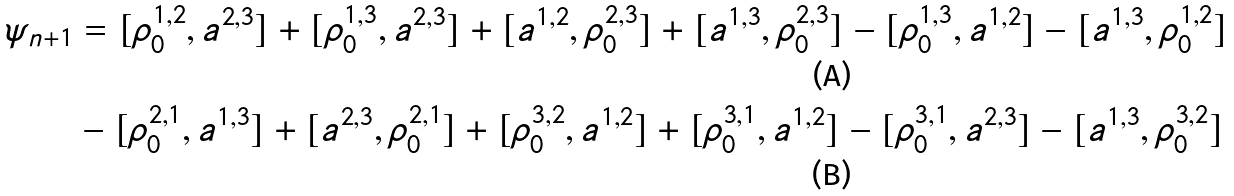<formula> <loc_0><loc_0><loc_500><loc_500>\psi _ { n + 1 } & = [ \rho _ { 0 } ^ { 1 , 2 } , a ^ { 2 , 3 } ] + [ \rho _ { 0 } ^ { 1 , 3 } , a ^ { 2 , 3 } ] + [ a ^ { 1 , 2 } , \rho _ { 0 } ^ { 2 , 3 } ] + [ a ^ { 1 , 3 } , \rho _ { 0 } ^ { 2 , 3 } ] - [ \rho _ { 0 } ^ { 1 , 3 } , a ^ { 1 , 2 } ] - [ a ^ { 1 , 3 } , \rho _ { 0 } ^ { 1 , 2 } ] \\ & - [ \rho _ { 0 } ^ { 2 , 1 } , a ^ { 1 , 3 } ] + [ a ^ { 2 , 3 } , \rho _ { 0 } ^ { 2 , 1 } ] + [ \rho _ { 0 } ^ { 3 , 2 } , a ^ { 1 , 2 } ] + [ \rho _ { 0 } ^ { 3 , 1 } , a ^ { 1 , 2 } ] - [ \rho _ { 0 } ^ { 3 , 1 } , a ^ { 2 , 3 } ] - [ a ^ { 1 , 3 } , \rho _ { 0 } ^ { 3 , 2 } ]</formula> 